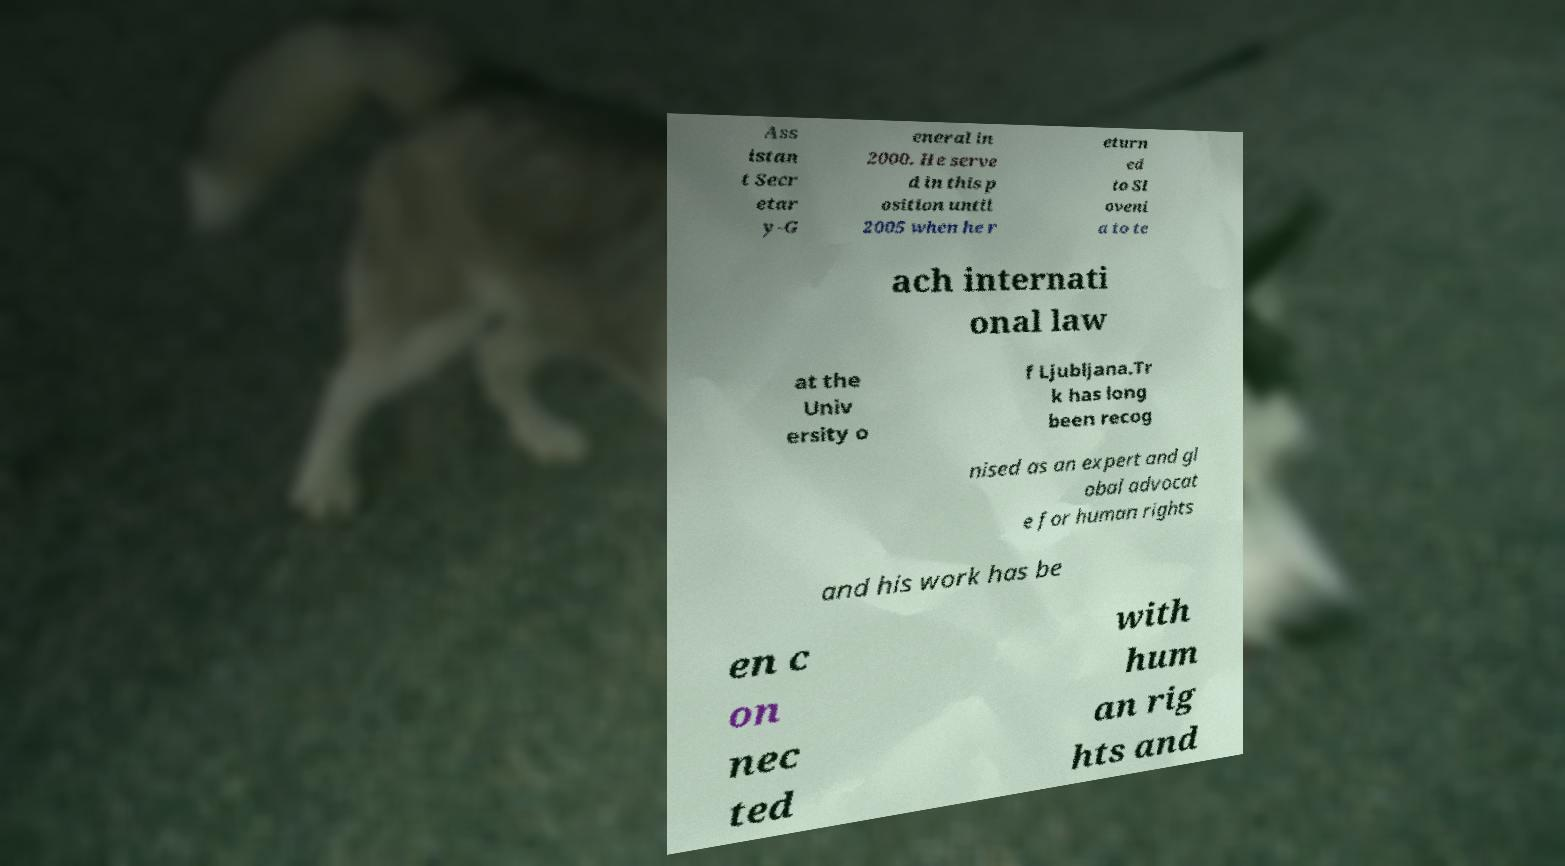Could you assist in decoding the text presented in this image and type it out clearly? Ass istan t Secr etar y-G eneral in 2000. He serve d in this p osition until 2005 when he r eturn ed to Sl oveni a to te ach internati onal law at the Univ ersity o f Ljubljana.Tr k has long been recog nised as an expert and gl obal advocat e for human rights and his work has be en c on nec ted with hum an rig hts and 